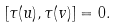<formula> <loc_0><loc_0><loc_500><loc_500>[ \tau ( u ) , \tau ( v ) ] = 0 .</formula> 